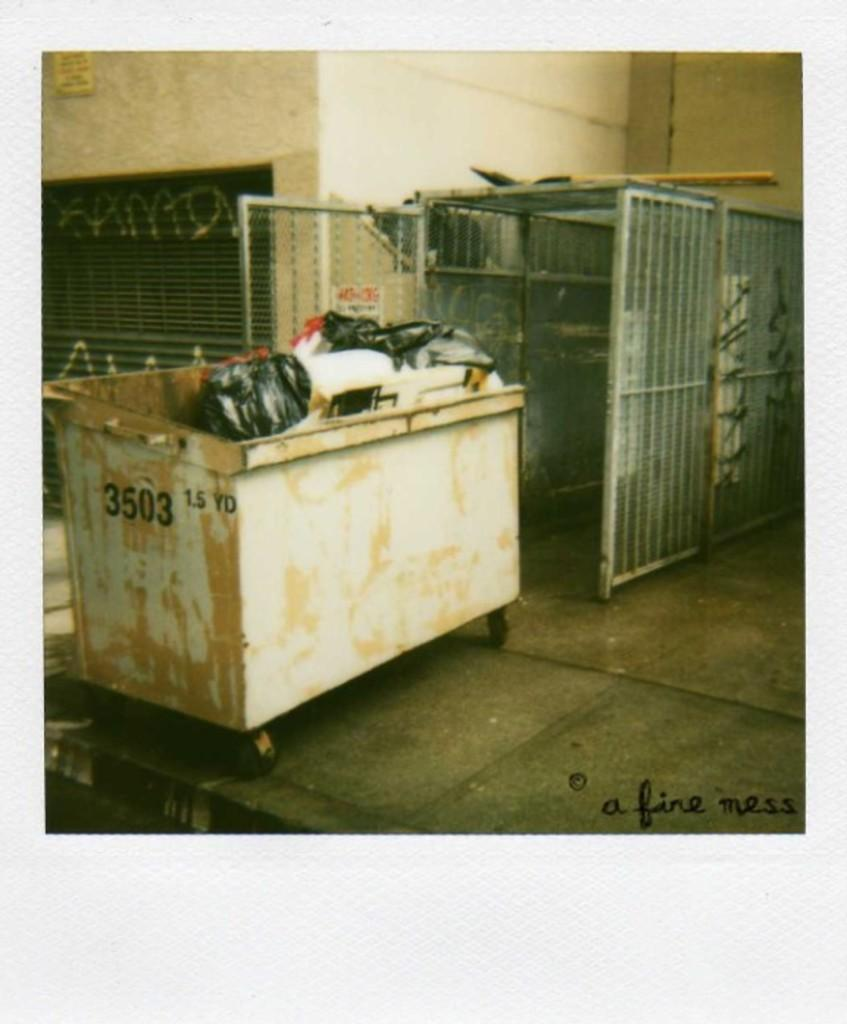Provide a one-sentence caption for the provided image. a beige dumpster peeling white paint with the numbers 3503 on it. 